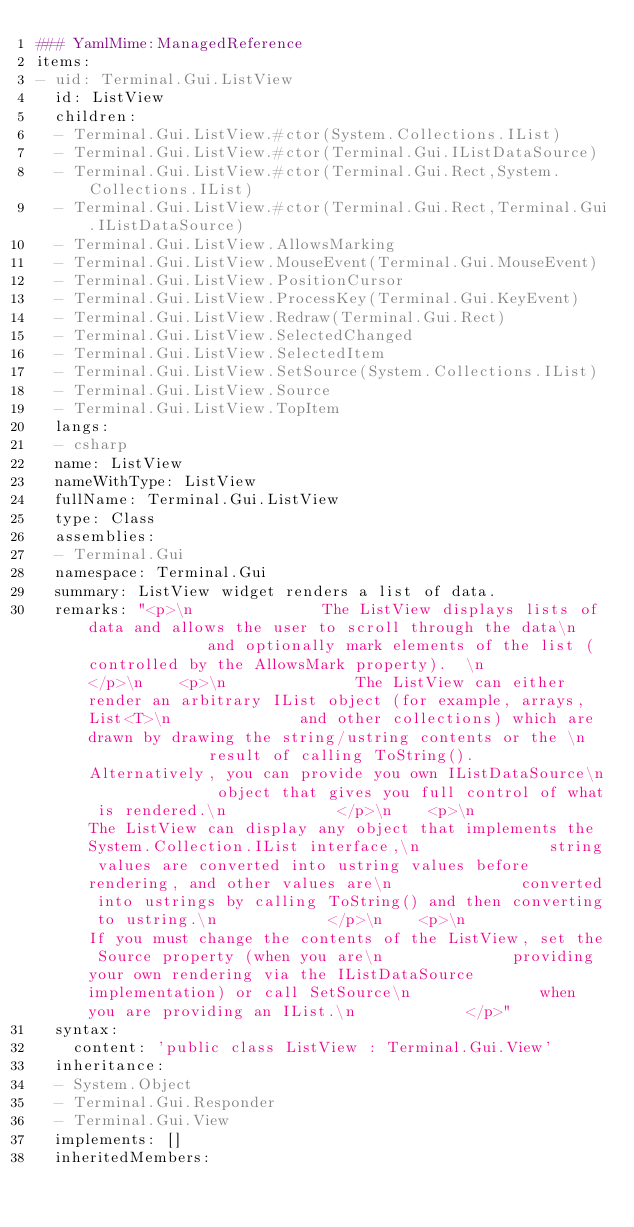Convert code to text. <code><loc_0><loc_0><loc_500><loc_500><_YAML_>### YamlMime:ManagedReference
items:
- uid: Terminal.Gui.ListView
  id: ListView
  children:
  - Terminal.Gui.ListView.#ctor(System.Collections.IList)
  - Terminal.Gui.ListView.#ctor(Terminal.Gui.IListDataSource)
  - Terminal.Gui.ListView.#ctor(Terminal.Gui.Rect,System.Collections.IList)
  - Terminal.Gui.ListView.#ctor(Terminal.Gui.Rect,Terminal.Gui.IListDataSource)
  - Terminal.Gui.ListView.AllowsMarking
  - Terminal.Gui.ListView.MouseEvent(Terminal.Gui.MouseEvent)
  - Terminal.Gui.ListView.PositionCursor
  - Terminal.Gui.ListView.ProcessKey(Terminal.Gui.KeyEvent)
  - Terminal.Gui.ListView.Redraw(Terminal.Gui.Rect)
  - Terminal.Gui.ListView.SelectedChanged
  - Terminal.Gui.ListView.SelectedItem
  - Terminal.Gui.ListView.SetSource(System.Collections.IList)
  - Terminal.Gui.ListView.Source
  - Terminal.Gui.ListView.TopItem
  langs:
  - csharp
  name: ListView
  nameWithType: ListView
  fullName: Terminal.Gui.ListView
  type: Class
  assemblies:
  - Terminal.Gui
  namespace: Terminal.Gui
  summary: ListView widget renders a list of data.
  remarks: "<p>\n              The ListView displays lists of data and allows the user to scroll through the data\n              and optionally mark elements of the list (controlled by the AllowsMark property).  \n            </p>\n    <p>\n              The ListView can either render an arbitrary IList object (for example, arrays, List<T>\n              and other collections) which are drawn by drawing the string/ustring contents or the \n              result of calling ToString().   Alternatively, you can provide you own IListDataSource\n              object that gives you full control of what is rendered.\n            </p>\n    <p>\n              The ListView can display any object that implements the System.Collection.IList interface,\n              string values are converted into ustring values before rendering, and other values are\n              converted into ustrings by calling ToString() and then converting to ustring.\n            </p>\n    <p>\n              If you must change the contents of the ListView, set the Source property (when you are\n              providing your own rendering via the IListDataSource implementation) or call SetSource\n              when you are providing an IList.\n            </p>"
  syntax:
    content: 'public class ListView : Terminal.Gui.View'
  inheritance:
  - System.Object
  - Terminal.Gui.Responder
  - Terminal.Gui.View
  implements: []
  inheritedMembers:</code> 